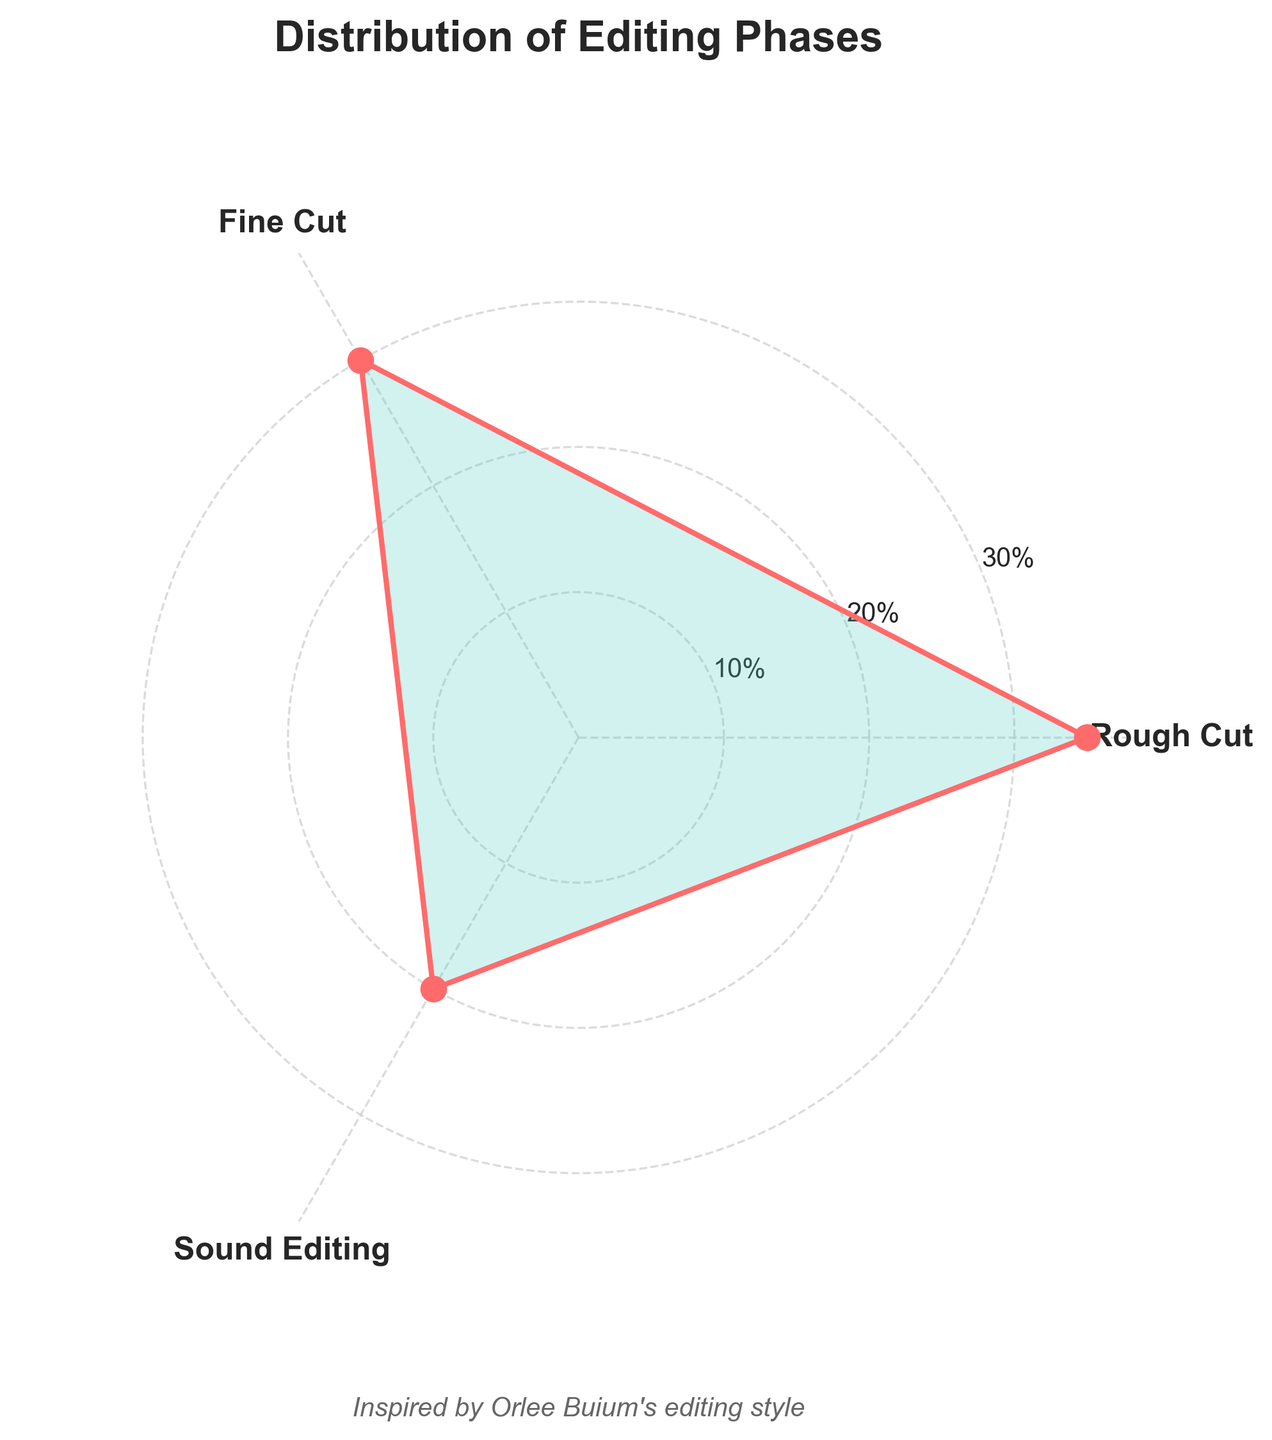What's the title of the figure? The title of the figure is displayed at the top. It provides a summary of what the chart represents, which in this case mentions the distribution of different editing phases.
Answer: Distribution of Editing Phases Which editing phase has the highest percentage? To answer this, observe the radial distances of the markers on the rose chart. The phase with the farthest marker from the center corresponds to the highest percentage.
Answer: Rough Cut Which color is used to fill the area representing the phases? By examining the filled area of the plot, we can see that it is shaded with a light color.
Answer: Light turquoise How many phases are shown in the chart? Count the distinct labels around the radar chart. Each label represents an editing phase.
Answer: 3 What is the average percentage of the three editing phases shown? To find the average, add the percentages of Rough Cut, Fine Cut, and Sound Editing, then divide by 3. (35 + 30 + 20) / 3 = 28.33
Answer: 28.33% How much greater is the percentage of Rough Cut compared to Fine Cut? Subtract the Fine Cut percentage from the Rough Cut percentage to determine the difference. 35 - 30 = 5
Answer: 5% What is the combined percentage of Fine Cut and Sound Editing? Add the percentages for Fine Cut and Sound Editing to get the combined value. 30 + 20 = 50
Answer: 50% Which editing phase is represented next to Rough Cut in the clockwise direction? Look at the labels around the chart following the Rough Cut label clockwise to identify the neighboring phase.
Answer: Fine Cut What visual elements are used to embellish the chart? The chart uses various elements like marker points, filled colors, grid lines, and a title, as well as text inspired by Orlee Buium's style.
Answer: Marker points, filled colors, grid lines, title, text 